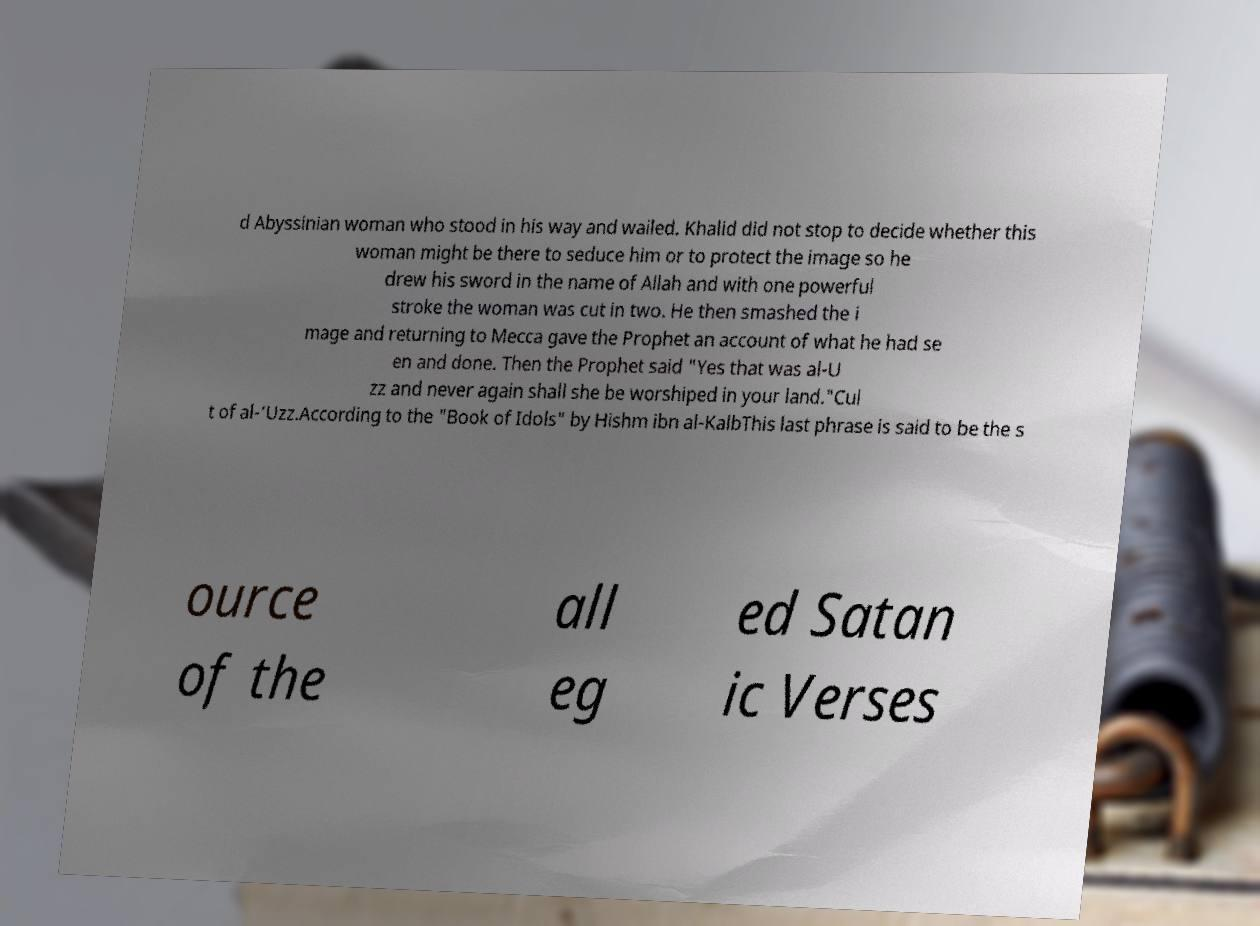What messages or text are displayed in this image? I need them in a readable, typed format. d Abyssinian woman who stood in his way and wailed. Khalid did not stop to decide whether this woman might be there to seduce him or to protect the image so he drew his sword in the name of Allah and with one powerful stroke the woman was cut in two. He then smashed the i mage and returning to Mecca gave the Prophet an account of what he had se en and done. Then the Prophet said "Yes that was al-U zz and never again shall she be worshiped in your land."Cul t of al-‘Uzz.According to the "Book of Idols" by Hishm ibn al-KalbThis last phrase is said to be the s ource of the all eg ed Satan ic Verses 